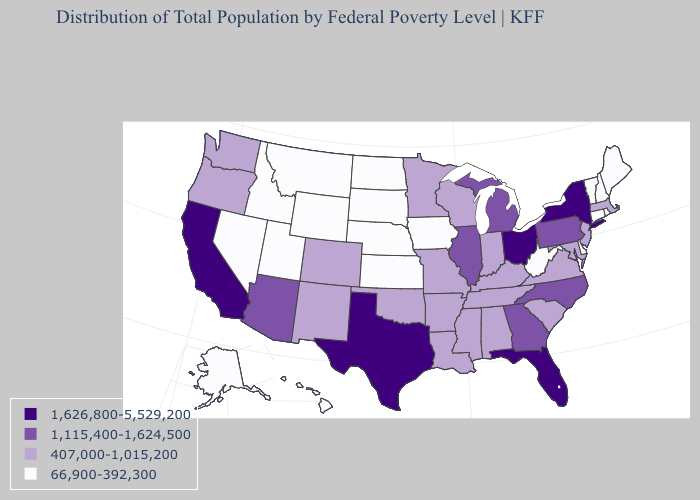What is the highest value in the USA?
Short answer required. 1,626,800-5,529,200. What is the value of Arkansas?
Short answer required. 407,000-1,015,200. What is the highest value in states that border South Dakota?
Keep it brief. 407,000-1,015,200. Name the states that have a value in the range 66,900-392,300?
Write a very short answer. Alaska, Connecticut, Delaware, Hawaii, Idaho, Iowa, Kansas, Maine, Montana, Nebraska, Nevada, New Hampshire, North Dakota, Rhode Island, South Dakota, Utah, Vermont, West Virginia, Wyoming. Which states have the highest value in the USA?
Give a very brief answer. California, Florida, New York, Ohio, Texas. Does Wisconsin have the highest value in the MidWest?
Quick response, please. No. Among the states that border Mississippi , which have the highest value?
Write a very short answer. Alabama, Arkansas, Louisiana, Tennessee. Which states have the lowest value in the USA?
Keep it brief. Alaska, Connecticut, Delaware, Hawaii, Idaho, Iowa, Kansas, Maine, Montana, Nebraska, Nevada, New Hampshire, North Dakota, Rhode Island, South Dakota, Utah, Vermont, West Virginia, Wyoming. Which states have the lowest value in the USA?
Short answer required. Alaska, Connecticut, Delaware, Hawaii, Idaho, Iowa, Kansas, Maine, Montana, Nebraska, Nevada, New Hampshire, North Dakota, Rhode Island, South Dakota, Utah, Vermont, West Virginia, Wyoming. Does Florida have the highest value in the USA?
Write a very short answer. Yes. Does the first symbol in the legend represent the smallest category?
Answer briefly. No. Does Wyoming have the same value as Kansas?
Write a very short answer. Yes. Does New Jersey have the highest value in the USA?
Write a very short answer. No. Name the states that have a value in the range 66,900-392,300?
Give a very brief answer. Alaska, Connecticut, Delaware, Hawaii, Idaho, Iowa, Kansas, Maine, Montana, Nebraska, Nevada, New Hampshire, North Dakota, Rhode Island, South Dakota, Utah, Vermont, West Virginia, Wyoming. Which states hav the highest value in the MidWest?
Quick response, please. Ohio. 